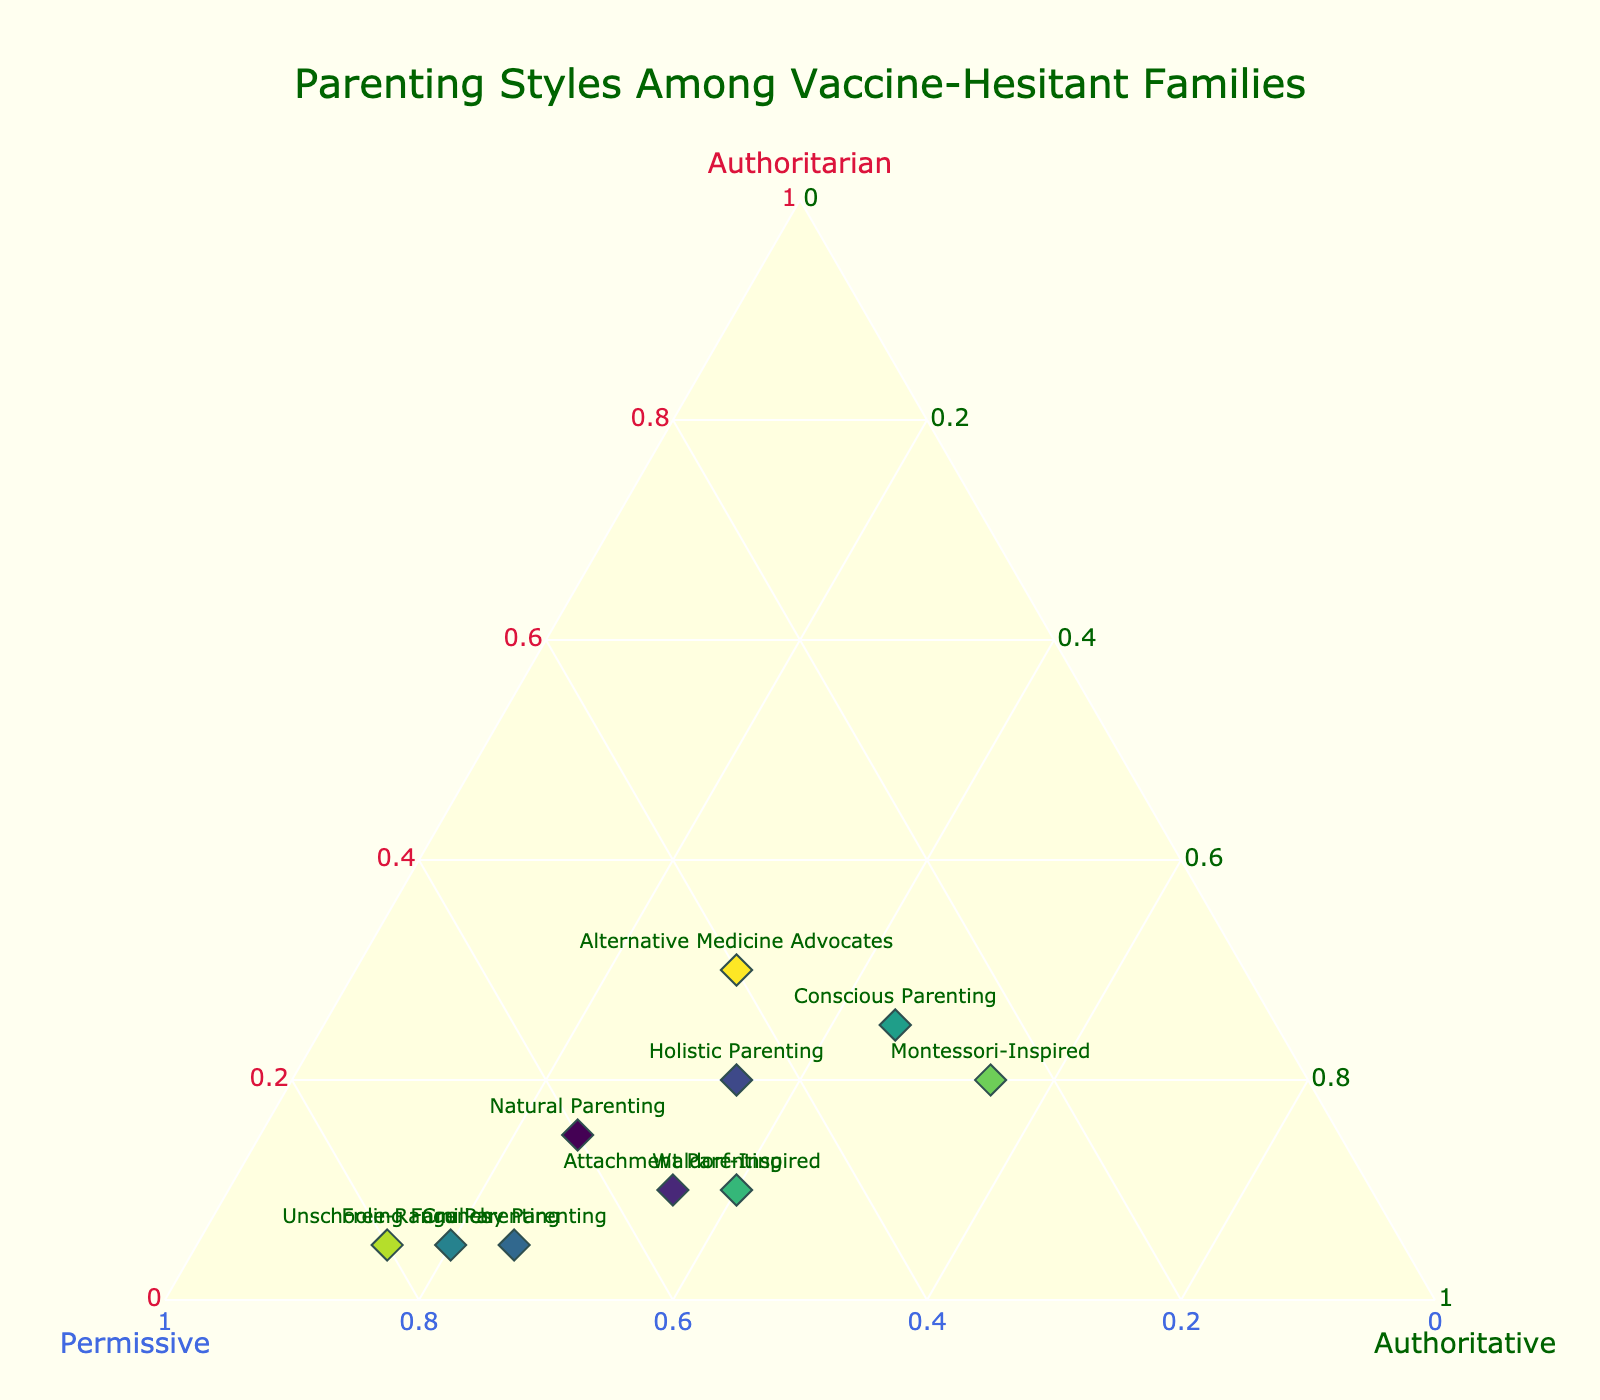How many parenting styles are represented in the plot? The plot displays points for each parenting style. By counting the number of data points or labels shown in the plot, you can determine there are 10 parenting styles represented.
Answer: 10 What is the proportion of permissiveness for Unschooling Families? In the plot, each point is positioned based on the proportions of parenting styles. The label for "Unschooling Families" is associated with values, with "Permissive" showing 0.80.
Answer: 0.80 Which parenting style has the highest authoritarian proportion? Check the points plotted near the "Authoritarian" axis. The label with the highest Authoritarian value is "Alternative Medicine Advocates" with a proportion of 0.30.
Answer: Alternative Medicine Advocates What is the average proportion of permissiveness among all parenting styles? Sum all permissive proportions: (0.60 + 0.55 + 0.45 + 0.70 + 0.75 + 0.30 + 0.50 + 0.25 + 0.80 + 0.40) = 5.30. Divide by total parenting styles (10), resulting in 5.30/10.
Answer: 0.53 Which parenting style has the most balanced proportions? Look for points near the center of the ternary plot where the values of Authoritarian, Permissive, and Authoritative are relatively equal. "Conscious Parenting" seems most balanced with values (0.25, 0.30, 0.45).
Answer: Conscious Parenting How many parenting styles have a permissiveness proportion greater than 0.50? Identify labels having values greater than 0.50 for permissiveness. These are Natural Parenting, Attachment Parenting, Crunchy Parenting, Free-Range Parenting, Unschooling Families (5 in total).
Answer: 5 Which two parenting styles have equal proportions of authoritarian? Comparing the "Authoritarian" values visually, a match for equal proportions exists with "Free-Range Parenting" and "Unschooling Families," both having 0.05.
Answer: Free-Range Parenting and Unschooling Families Is there any parenting style where the permissive proportion is closest to zero? Reviewing the "Permissive" axis closely indicates "Montessori-Inspired" has the lowest permissive proportion of 0.25.
Answer: Montessori-Inspired What is the difference in the authoritative proportion between Conscious Parenting and Montessori-Inspired? "Conscious Parenting" has 0.45 while "Montessori-Inspired" shows 0.55. Subtract the lower from the higher: 0.55 - 0.45 = 0.10.
Answer: 0.10 Which parenting style is closest to being fully permissive? Points near the "Permissive" axis closer to 1 display high permissiveness. "Unschooling Families" is closest with a value of 0.80.
Answer: Unschooling Families 